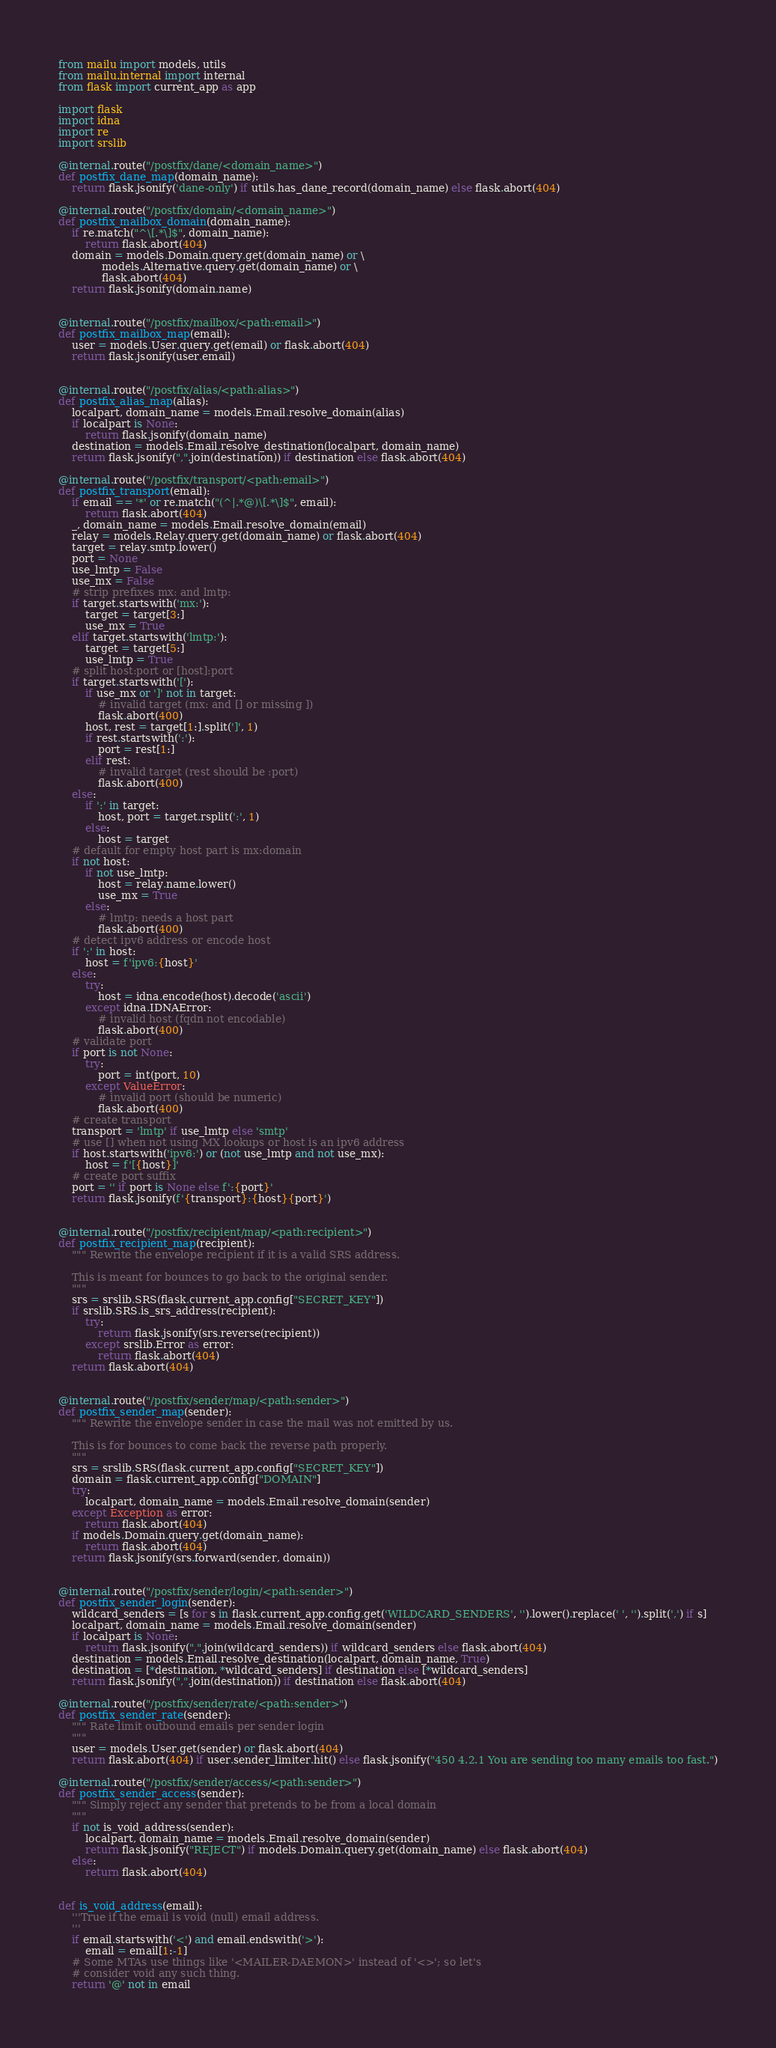Convert code to text. <code><loc_0><loc_0><loc_500><loc_500><_Python_>from mailu import models, utils
from mailu.internal import internal
from flask import current_app as app

import flask
import idna
import re
import srslib

@internal.route("/postfix/dane/<domain_name>")
def postfix_dane_map(domain_name):
    return flask.jsonify('dane-only') if utils.has_dane_record(domain_name) else flask.abort(404)

@internal.route("/postfix/domain/<domain_name>")
def postfix_mailbox_domain(domain_name):
    if re.match("^\[.*\]$", domain_name):
        return flask.abort(404)
    domain = models.Domain.query.get(domain_name) or \
             models.Alternative.query.get(domain_name) or \
             flask.abort(404)
    return flask.jsonify(domain.name)


@internal.route("/postfix/mailbox/<path:email>")
def postfix_mailbox_map(email):
    user = models.User.query.get(email) or flask.abort(404)
    return flask.jsonify(user.email)


@internal.route("/postfix/alias/<path:alias>")
def postfix_alias_map(alias):
    localpart, domain_name = models.Email.resolve_domain(alias)
    if localpart is None:
        return flask.jsonify(domain_name)
    destination = models.Email.resolve_destination(localpart, domain_name)
    return flask.jsonify(",".join(destination)) if destination else flask.abort(404)

@internal.route("/postfix/transport/<path:email>")
def postfix_transport(email):
    if email == '*' or re.match("(^|.*@)\[.*\]$", email):
        return flask.abort(404)
    _, domain_name = models.Email.resolve_domain(email)
    relay = models.Relay.query.get(domain_name) or flask.abort(404)
    target = relay.smtp.lower()
    port = None
    use_lmtp = False
    use_mx = False
    # strip prefixes mx: and lmtp:
    if target.startswith('mx:'):
        target = target[3:]
        use_mx = True
    elif target.startswith('lmtp:'):
        target = target[5:]
        use_lmtp = True
    # split host:port or [host]:port
    if target.startswith('['):
        if use_mx or ']' not in target:
            # invalid target (mx: and [] or missing ])
            flask.abort(400)
        host, rest = target[1:].split(']', 1)
        if rest.startswith(':'):
            port = rest[1:]
        elif rest:
            # invalid target (rest should be :port)
            flask.abort(400)
    else:
        if ':' in target:
            host, port = target.rsplit(':', 1)
        else:
            host = target
    # default for empty host part is mx:domain
    if not host:
        if not use_lmtp:
            host = relay.name.lower()
            use_mx = True
        else:
            # lmtp: needs a host part
            flask.abort(400)
    # detect ipv6 address or encode host
    if ':' in host:
        host = f'ipv6:{host}'
    else:
        try:
            host = idna.encode(host).decode('ascii')
        except idna.IDNAError:
            # invalid host (fqdn not encodable)
            flask.abort(400)
    # validate port
    if port is not None:
        try:
            port = int(port, 10)
        except ValueError:
            # invalid port (should be numeric)
            flask.abort(400)
    # create transport
    transport = 'lmtp' if use_lmtp else 'smtp'
    # use [] when not using MX lookups or host is an ipv6 address
    if host.startswith('ipv6:') or (not use_lmtp and not use_mx):
        host = f'[{host}]'
    # create port suffix
    port = '' if port is None else f':{port}'
    return flask.jsonify(f'{transport}:{host}{port}')


@internal.route("/postfix/recipient/map/<path:recipient>")
def postfix_recipient_map(recipient):
    """ Rewrite the envelope recipient if it is a valid SRS address.

    This is meant for bounces to go back to the original sender.
    """
    srs = srslib.SRS(flask.current_app.config["SECRET_KEY"])
    if srslib.SRS.is_srs_address(recipient):
        try:
            return flask.jsonify(srs.reverse(recipient))
        except srslib.Error as error:
            return flask.abort(404)
    return flask.abort(404)


@internal.route("/postfix/sender/map/<path:sender>")
def postfix_sender_map(sender):
    """ Rewrite the envelope sender in case the mail was not emitted by us.

    This is for bounces to come back the reverse path properly.
    """
    srs = srslib.SRS(flask.current_app.config["SECRET_KEY"])
    domain = flask.current_app.config["DOMAIN"]
    try:
        localpart, domain_name = models.Email.resolve_domain(sender)
    except Exception as error:
        return flask.abort(404)
    if models.Domain.query.get(domain_name):
        return flask.abort(404)
    return flask.jsonify(srs.forward(sender, domain))


@internal.route("/postfix/sender/login/<path:sender>")
def postfix_sender_login(sender):
    wildcard_senders = [s for s in flask.current_app.config.get('WILDCARD_SENDERS', '').lower().replace(' ', '').split(',') if s]
    localpart, domain_name = models.Email.resolve_domain(sender)
    if localpart is None:
        return flask.jsonify(",".join(wildcard_senders)) if wildcard_senders else flask.abort(404)
    destination = models.Email.resolve_destination(localpart, domain_name, True)
    destination = [*destination, *wildcard_senders] if destination else [*wildcard_senders]
    return flask.jsonify(",".join(destination)) if destination else flask.abort(404)

@internal.route("/postfix/sender/rate/<path:sender>")
def postfix_sender_rate(sender):
    """ Rate limit outbound emails per sender login
    """
    user = models.User.get(sender) or flask.abort(404)
    return flask.abort(404) if user.sender_limiter.hit() else flask.jsonify("450 4.2.1 You are sending too many emails too fast.")

@internal.route("/postfix/sender/access/<path:sender>")
def postfix_sender_access(sender):
    """ Simply reject any sender that pretends to be from a local domain
    """
    if not is_void_address(sender):
        localpart, domain_name = models.Email.resolve_domain(sender)
        return flask.jsonify("REJECT") if models.Domain.query.get(domain_name) else flask.abort(404)
    else:
        return flask.abort(404)


def is_void_address(email):
    '''True if the email is void (null) email address.
    '''
    if email.startswith('<') and email.endswith('>'):
        email = email[1:-1]
    # Some MTAs use things like '<MAILER-DAEMON>' instead of '<>'; so let's
    # consider void any such thing.
    return '@' not in email
</code> 